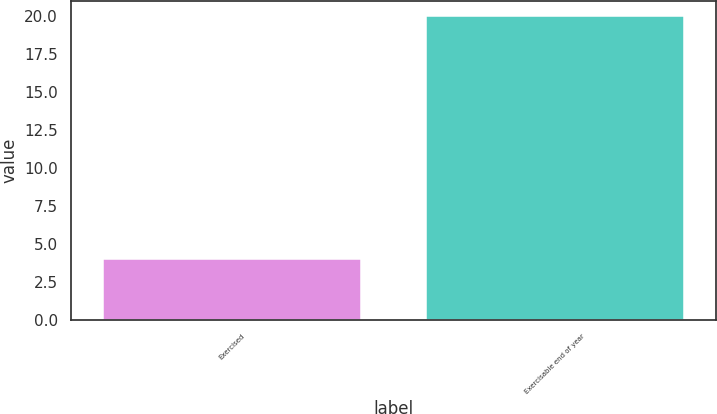Convert chart to OTSL. <chart><loc_0><loc_0><loc_500><loc_500><bar_chart><fcel>Exercised<fcel>Exercisable end of year<nl><fcel>4<fcel>20<nl></chart> 